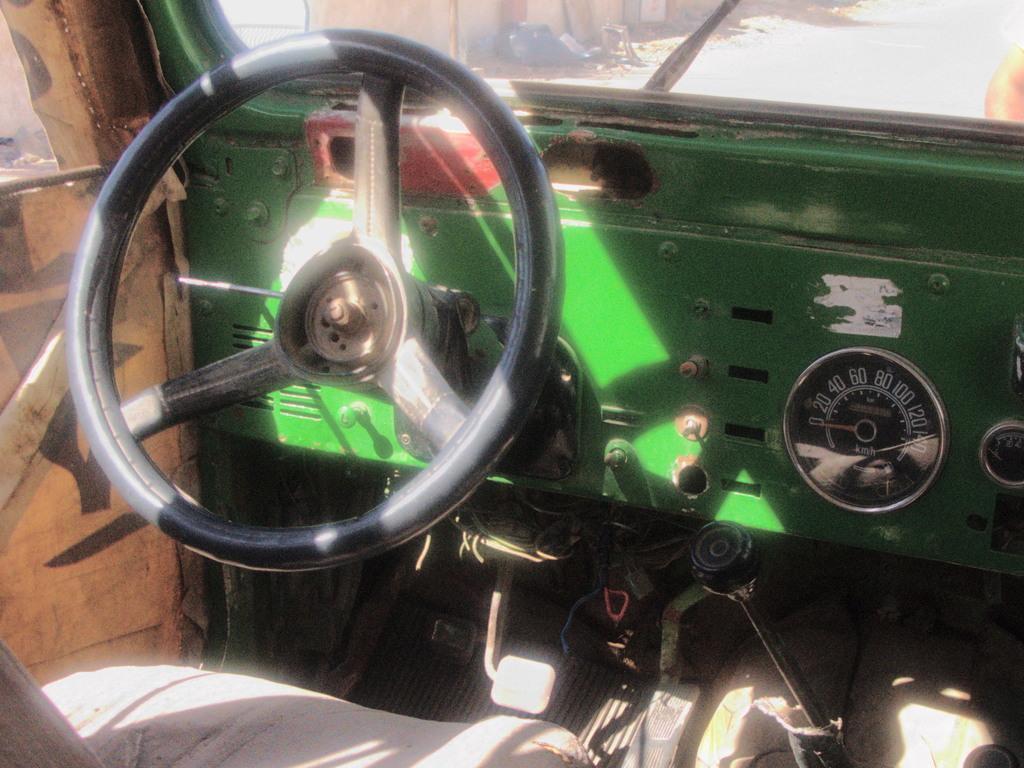In one or two sentences, can you explain what this image depicts? In this image we can see steering, speedometer, accelerator, mirror, road, seat and door. 